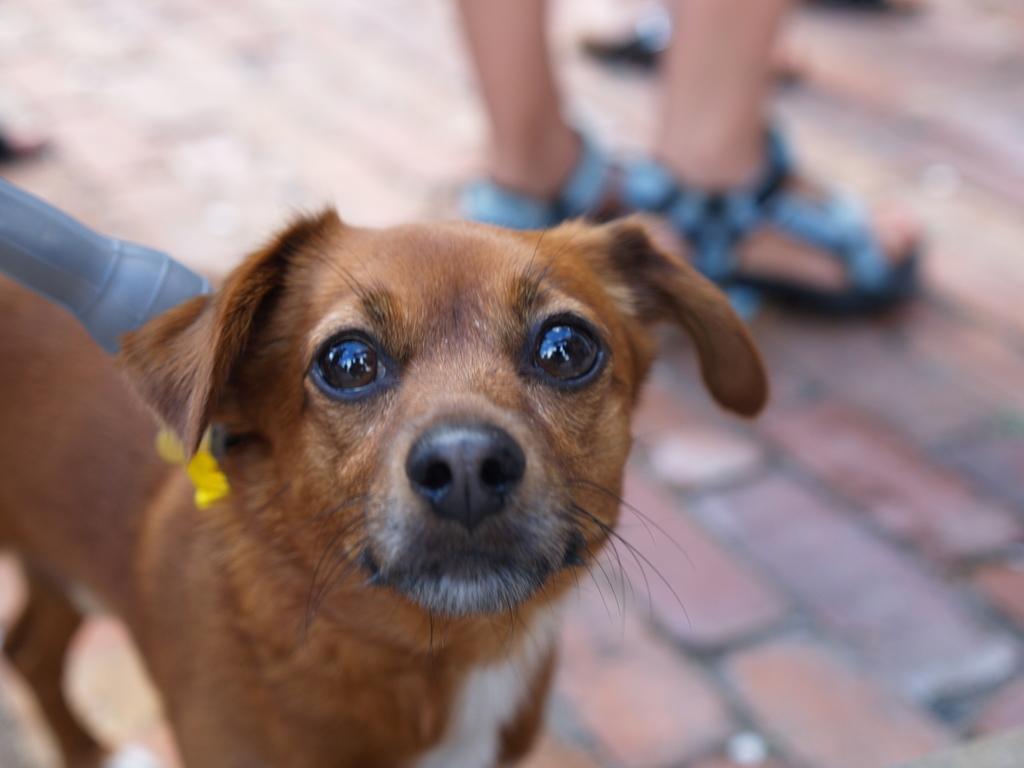In one or two sentences, can you explain what this image depicts? In this image I can see a dog, object and a person on the road. This image is taken may be during a day. 